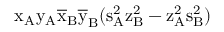Convert formula to latex. <formula><loc_0><loc_0><loc_500><loc_500>x _ { A } \mathrm { y _ { A } \mathrm { \overline { x } _ { B } \mathrm { \overline { y } _ { B } ( \mathrm { s _ { A } ^ { 2 } \mathrm { z _ { B } ^ { 2 } - \mathrm { z _ { A } ^ { 2 } \mathrm { s _ { B } ^ { 2 } ) } } } } } } }</formula> 